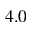<formula> <loc_0><loc_0><loc_500><loc_500>4 . 0</formula> 